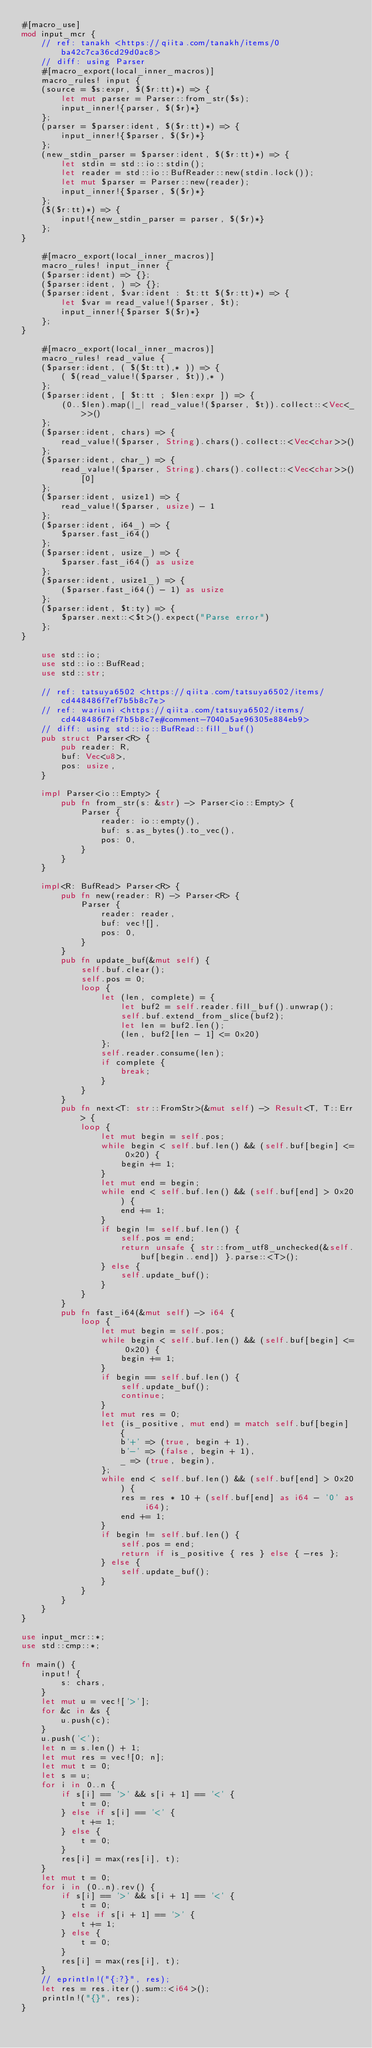Convert code to text. <code><loc_0><loc_0><loc_500><loc_500><_Rust_>#[macro_use]
mod input_mcr {
    // ref: tanakh <https://qiita.com/tanakh/items/0ba42c7ca36cd29d0ac8>
    // diff: using Parser
    #[macro_export(local_inner_macros)]
    macro_rules! input {
    (source = $s:expr, $($r:tt)*) => {
        let mut parser = Parser::from_str($s);
        input_inner!{parser, $($r)*}
    };
    (parser = $parser:ident, $($r:tt)*) => {
        input_inner!{$parser, $($r)*}
    };
    (new_stdin_parser = $parser:ident, $($r:tt)*) => {
        let stdin = std::io::stdin();
        let reader = std::io::BufReader::new(stdin.lock());
        let mut $parser = Parser::new(reader);
        input_inner!{$parser, $($r)*}
    };
    ($($r:tt)*) => {
        input!{new_stdin_parser = parser, $($r)*}
    };
}

    #[macro_export(local_inner_macros)]
    macro_rules! input_inner {
    ($parser:ident) => {};
    ($parser:ident, ) => {};
    ($parser:ident, $var:ident : $t:tt $($r:tt)*) => {
        let $var = read_value!($parser, $t);
        input_inner!{$parser $($r)*}
    };
}

    #[macro_export(local_inner_macros)]
    macro_rules! read_value {
    ($parser:ident, ( $($t:tt),* )) => {
        ( $(read_value!($parser, $t)),* )
    };
    ($parser:ident, [ $t:tt ; $len:expr ]) => {
        (0..$len).map(|_| read_value!($parser, $t)).collect::<Vec<_>>()
    };
    ($parser:ident, chars) => {
        read_value!($parser, String).chars().collect::<Vec<char>>()
    };
    ($parser:ident, char_) => {
        read_value!($parser, String).chars().collect::<Vec<char>>()[0]
    };
    ($parser:ident, usize1) => {
        read_value!($parser, usize) - 1
    };
    ($parser:ident, i64_) => {
        $parser.fast_i64()
    };
    ($parser:ident, usize_) => {
        $parser.fast_i64() as usize
    };
    ($parser:ident, usize1_) => {
        ($parser.fast_i64() - 1) as usize
    };
    ($parser:ident, $t:ty) => {
        $parser.next::<$t>().expect("Parse error")
    };
}

    use std::io;
    use std::io::BufRead;
    use std::str;

    // ref: tatsuya6502 <https://qiita.com/tatsuya6502/items/cd448486f7ef7b5b8c7e>
    // ref: wariuni <https://qiita.com/tatsuya6502/items/cd448486f7ef7b5b8c7e#comment-7040a5ae96305e884eb9>
    // diff: using std::io::BufRead::fill_buf()
    pub struct Parser<R> {
        pub reader: R,
        buf: Vec<u8>,
        pos: usize,
    }

    impl Parser<io::Empty> {
        pub fn from_str(s: &str) -> Parser<io::Empty> {
            Parser {
                reader: io::empty(),
                buf: s.as_bytes().to_vec(),
                pos: 0,
            }
        }
    }

    impl<R: BufRead> Parser<R> {
        pub fn new(reader: R) -> Parser<R> {
            Parser {
                reader: reader,
                buf: vec![],
                pos: 0,
            }
        }
        pub fn update_buf(&mut self) {
            self.buf.clear();
            self.pos = 0;
            loop {
                let (len, complete) = {
                    let buf2 = self.reader.fill_buf().unwrap();
                    self.buf.extend_from_slice(buf2);
                    let len = buf2.len();
                    (len, buf2[len - 1] <= 0x20)
                };
                self.reader.consume(len);
                if complete {
                    break;
                }
            }
        }
        pub fn next<T: str::FromStr>(&mut self) -> Result<T, T::Err> {
            loop {
                let mut begin = self.pos;
                while begin < self.buf.len() && (self.buf[begin] <= 0x20) {
                    begin += 1;
                }
                let mut end = begin;
                while end < self.buf.len() && (self.buf[end] > 0x20) {
                    end += 1;
                }
                if begin != self.buf.len() {
                    self.pos = end;
                    return unsafe { str::from_utf8_unchecked(&self.buf[begin..end]) }.parse::<T>();
                } else {
                    self.update_buf();
                }
            }
        }
        pub fn fast_i64(&mut self) -> i64 {
            loop {
                let mut begin = self.pos;
                while begin < self.buf.len() && (self.buf[begin] <= 0x20) {
                    begin += 1;
                }
                if begin == self.buf.len() {
                    self.update_buf();
                    continue;
                }
                let mut res = 0;
                let (is_positive, mut end) = match self.buf[begin] {
                    b'+' => (true, begin + 1),
                    b'-' => (false, begin + 1),
                    _ => (true, begin),
                };
                while end < self.buf.len() && (self.buf[end] > 0x20) {
                    res = res * 10 + (self.buf[end] as i64 - '0' as i64);
                    end += 1;
                }
                if begin != self.buf.len() {
                    self.pos = end;
                    return if is_positive { res } else { -res };
                } else {
                    self.update_buf();
                }
            }
        }
    }
}

use input_mcr::*;
use std::cmp::*;

fn main() {
    input! {
        s: chars,
    }
    let mut u = vec!['>'];
    for &c in &s {
        u.push(c);
    }
    u.push('<');
    let n = s.len() + 1;
    let mut res = vec![0; n];
    let mut t = 0;
    let s = u;
    for i in 0..n {
        if s[i] == '>' && s[i + 1] == '<' {
            t = 0;
        } else if s[i] == '<' {
            t += 1;
        } else {
            t = 0;
        }
        res[i] = max(res[i], t);
    }
    let mut t = 0;
    for i in (0..n).rev() {
        if s[i] == '>' && s[i + 1] == '<' {
            t = 0;
        } else if s[i + 1] == '>' {
            t += 1;
        } else {
            t = 0;
        }
        res[i] = max(res[i], t);
    }
    // eprintln!("{:?}", res);
    let res = res.iter().sum::<i64>();
    println!("{}", res);
}

</code> 